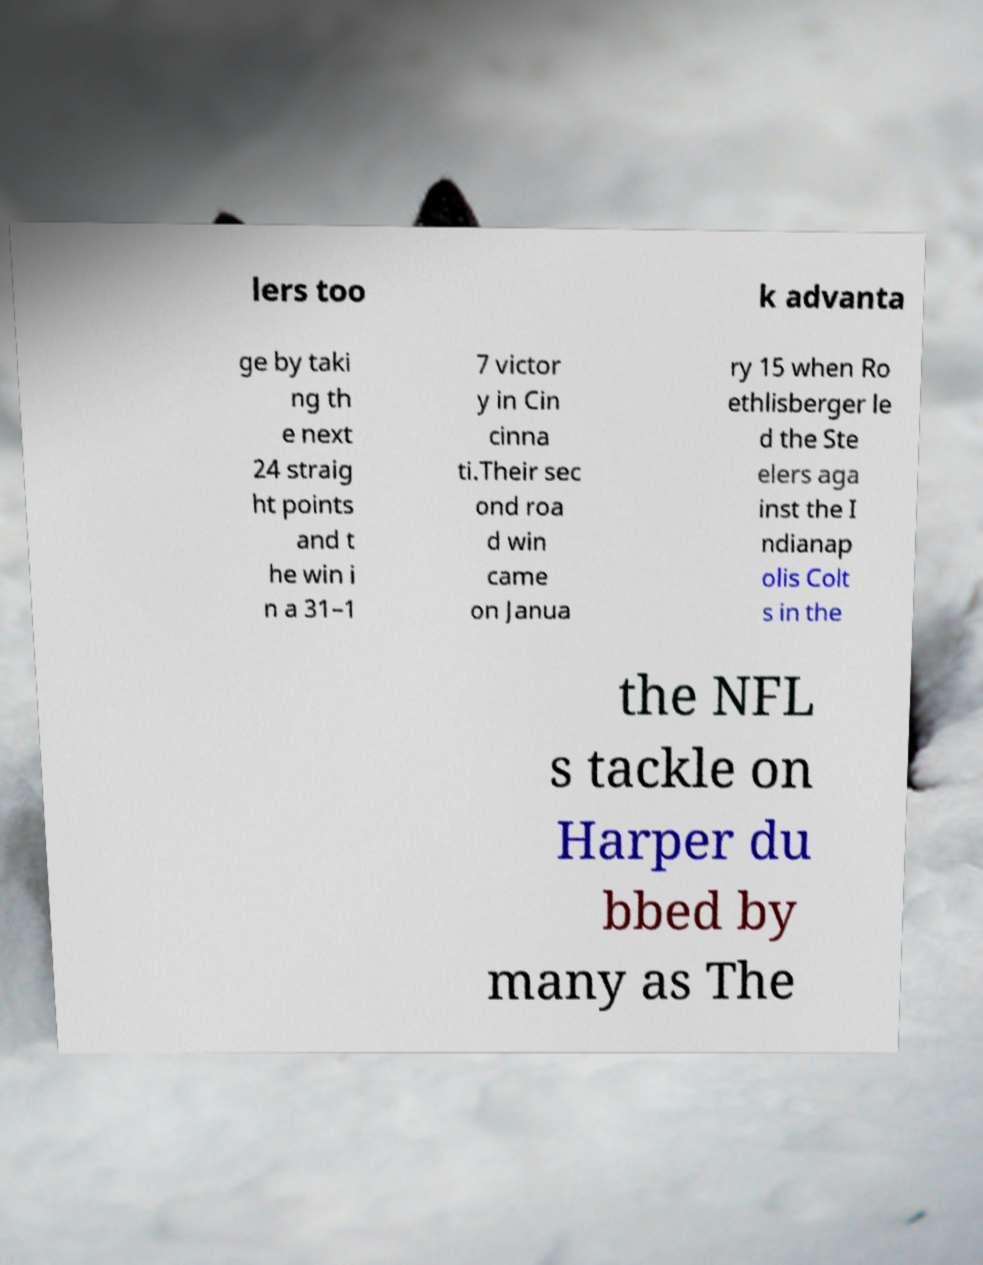Can you read and provide the text displayed in the image?This photo seems to have some interesting text. Can you extract and type it out for me? lers too k advanta ge by taki ng th e next 24 straig ht points and t he win i n a 31–1 7 victor y in Cin cinna ti.Their sec ond roa d win came on Janua ry 15 when Ro ethlisberger le d the Ste elers aga inst the I ndianap olis Colt s in the the NFL s tackle on Harper du bbed by many as The 